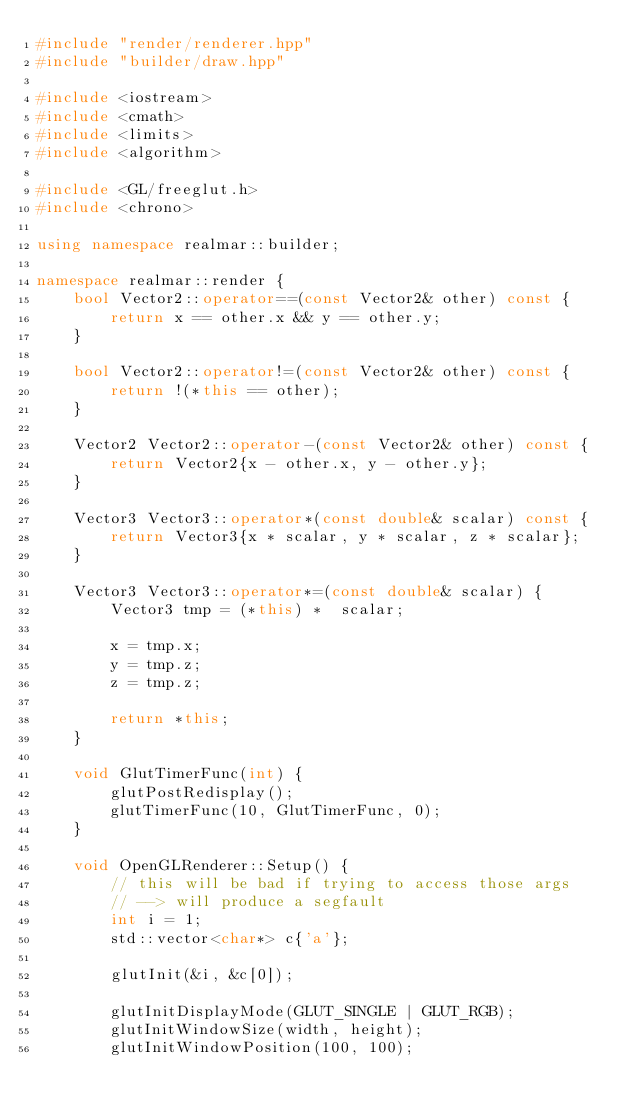<code> <loc_0><loc_0><loc_500><loc_500><_C++_>#include "render/renderer.hpp"
#include "builder/draw.hpp"

#include <iostream>
#include <cmath>
#include <limits>
#include <algorithm>

#include <GL/freeglut.h>
#include <chrono>

using namespace realmar::builder;

namespace realmar::render {
    bool Vector2::operator==(const Vector2& other) const {
        return x == other.x && y == other.y;
    }

    bool Vector2::operator!=(const Vector2& other) const {
        return !(*this == other);
    }

    Vector2 Vector2::operator-(const Vector2& other) const {
        return Vector2{x - other.x, y - other.y};
    }

    Vector3 Vector3::operator*(const double& scalar) const {
        return Vector3{x * scalar, y * scalar, z * scalar};
    }

    Vector3 Vector3::operator*=(const double& scalar) {
        Vector3 tmp = (*this) *  scalar;

        x = tmp.x;
        y = tmp.z;
        z = tmp.z;

        return *this;
    }

    void GlutTimerFunc(int) {
        glutPostRedisplay();
        glutTimerFunc(10, GlutTimerFunc, 0);
    }

    void OpenGLRenderer::Setup() {
        // this will be bad if trying to access those args
        // --> will produce a segfault
        int i = 1;
        std::vector<char*> c{'a'};

        glutInit(&i, &c[0]);

        glutInitDisplayMode(GLUT_SINGLE | GLUT_RGB);
        glutInitWindowSize(width, height);
        glutInitWindowPosition(100, 100);
</code> 